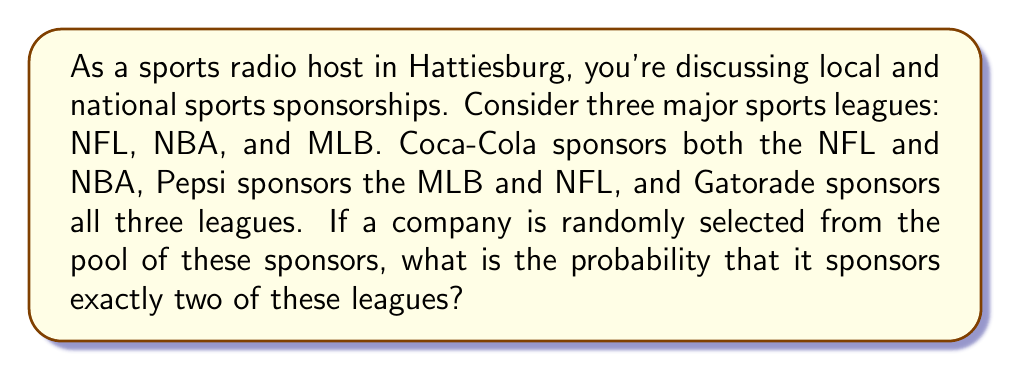Give your solution to this math problem. Let's approach this step-by-step using a Venn diagram:

1. First, let's draw a Venn diagram with three circles representing NFL, NBA, and MLB.

[asy]
unitsize(1cm);

pair A = (0,0), B = (1.5,0), C = (0.75,1.3);
real r = 1;

path circleA = circle(A,r);
path circleB = circle(B,r);
path circleC = circle(C,r);

fill(circleA,rgb(0.9,0.9,1));
fill(circleB,rgb(0.9,1,0.9));
fill(circleC,rgb(1,0.9,0.9));

draw(circleA);
draw(circleB);
draw(circleC);

label("NFL", A+(-0.7,-0.7));
label("NBA", B+(0.7,-0.7));
label("MLB", C+(0,0.7));

label("Coca-Cola", (A+B)/2);
label("Pepsi", (A+C)/2);
label("Gatorade", (A+B+C)/3);

[/asy]

2. From the given information:
   - Coca-Cola is in the intersection of NFL and NBA
   - Pepsi is in the intersection of MLB and NFL
   - Gatorade is in the intersection of all three

3. To find the probability, we need to count:
   - Total number of sponsors
   - Number of sponsors that sponsor exactly two leagues

4. Total number of sponsors:
   - Coca-Cola, Pepsi, and Gatorade = 3

5. Number of sponsors that sponsor exactly two leagues:
   - Coca-Cola (NFL and NBA)
   - Pepsi (MLB and NFL)
   - Total: 2

6. The probability is calculated as:

   $$P(\text{exactly two leagues}) = \frac{\text{favorable outcomes}}{\text{total outcomes}} = \frac{2}{3}$$
Answer: $\frac{2}{3}$ 